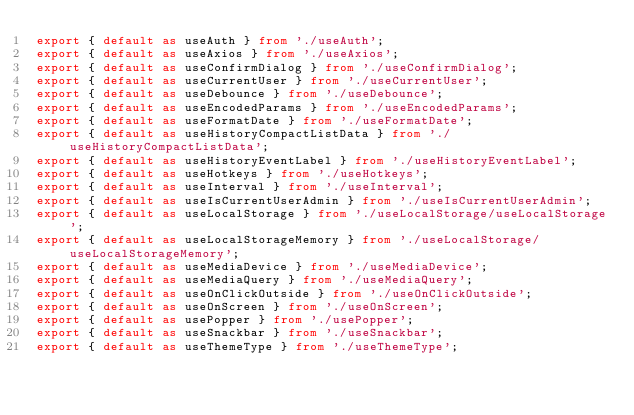Convert code to text. <code><loc_0><loc_0><loc_500><loc_500><_TypeScript_>export { default as useAuth } from './useAuth';
export { default as useAxios } from './useAxios';
export { default as useConfirmDialog } from './useConfirmDialog';
export { default as useCurrentUser } from './useCurrentUser';
export { default as useDebounce } from './useDebounce';
export { default as useEncodedParams } from './useEncodedParams';
export { default as useFormatDate } from './useFormatDate';
export { default as useHistoryCompactListData } from './useHistoryCompactListData';
export { default as useHistoryEventLabel } from './useHistoryEventLabel';
export { default as useHotkeys } from './useHotkeys';
export { default as useInterval } from './useInterval';
export { default as useIsCurrentUserAdmin } from './useIsCurrentUserAdmin';
export { default as useLocalStorage } from './useLocalStorage/useLocalStorage';
export { default as useLocalStorageMemory } from './useLocalStorage/useLocalStorageMemory';
export { default as useMediaDevice } from './useMediaDevice';
export { default as useMediaQuery } from './useMediaQuery';
export { default as useOnClickOutside } from './useOnClickOutside';
export { default as useOnScreen } from './useOnScreen';
export { default as usePopper } from './usePopper';
export { default as useSnackbar } from './useSnackbar';
export { default as useThemeType } from './useThemeType';
</code> 